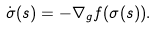Convert formula to latex. <formula><loc_0><loc_0><loc_500><loc_500>\dot { \sigma } ( s ) = - \nabla _ { g } f ( \sigma ( s ) ) .</formula> 